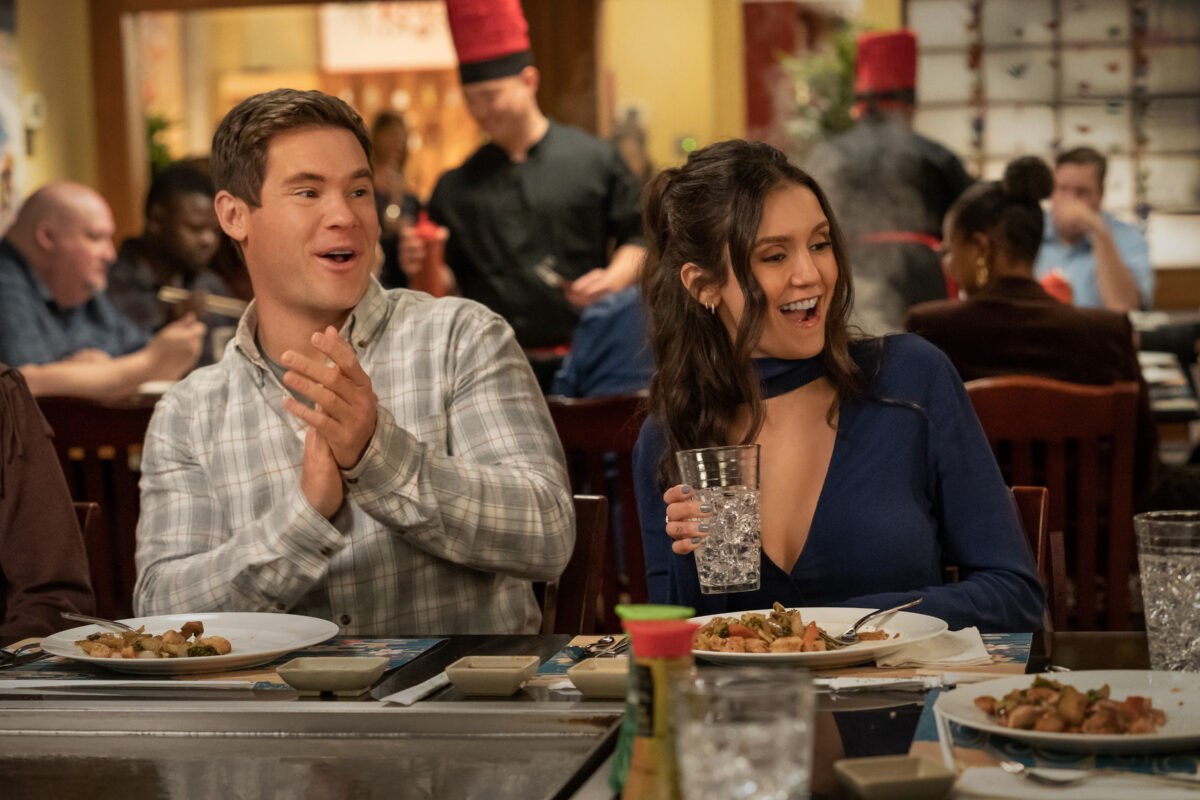Could you weave a creative story about the characters' background? Sure! Let's imagine that these two characters, Jessica and Alex, met during their university years. Jessica, the vibrant and ambitious psychology major, always had a knack for making people smile. Alex, the witty and charming business student, was drawn to her infectious energy. Fast forward a few years, they're now in the bustling heart of New York City. Jessica is a renowned therapist, known for her unconventional yet effective methods, and Alex owns a chain of successful artisanal coffee shops. Their dynamic friendship has always been marked by their mutual support and encouragement. Tonight, they're celebrating the second anniversary of Alex's entrepreneurial venture, which Jessica had a significant role in conceptualizing. Their laughter and joy are testaments to the deep bond they share, and the restaurant is alive with the energy of their shared history and accomplishments. Imagine a wild scenario where they are secret agents meeting for a covert mission. What would their conversation look like? Agent Jessica and Agent Alex, known in their circles as 'The Dynamic Duo', are undercover at a bustling restaurant, their unsuspecting faces lit with feigned cheer. Jessica, undercover in a stylish blue off-the-shoulder top, grips her glass of water with calculated casualness. Her eyes, however, are scanning the room. Alex, mid-clap, chuckles heartily, but his mind is focused on their covert mission. Their whispered conversation goes something like this:

Jessica: *smiling* 'Did you get the intel from the chef?' 
Alex: *clapping* 'Indeed, it’s under plate 4B. Our contact will retrieve it once we leave.'
Jessica: *laughing* 'Perfect. We need him to secure the perimeter by midnight. Any sign of our target?' 
Alex: *nodding slightly* 'He walked in five minutes ago, wearing a red tie. We leave in exactly three minutes. Stay on your guard.'
Their laughter masks the intensity of their real mission - to intercept a crucial microchip exchange happening within the next hour. As they prepare to leave, their jovial expressions are the perfect cover for the high-stakes operation unfolding around them.  Describe a realistic and casual interaction between them. In this casual setting at the bustling restaurant, Jessica and Alex are old friends catching up over a nice meal.

Jessica: *laughing* 'Remember that time in college when we tried to cook Thanksgiving dinner and almost set the kitchen on fire?' 
Alex: *clapping lightly* 'Oh man, how could I forget? I’ve never seen so much smoke in one place! I’m just glad we managed to salvage the pie, though.'
Jessica: 'Yeah, that pie was legendary. Who knew you could make pecan pie without pecans?' *laughs*
Alex: 'Desperate times called for desperate measures! So, tell me, how’s the new job treating you?' 
Jessica: 'It’s been great! Challenging but rewarding. I’ve got this amazing team I’m leading now…' 
Their conversation flows easily, punctuated by shared laughter and reminisces, reflecting the warmth and comfort of long-lasting friendship.  Describe another realistic but more serious scenario. In this scene, Alex and Jessica might be discussing a serious matter.

Alex: *clapping hands together thoughtfully* 'So, about that business proposal you mentioned last week. Did you manage to finalize the presentation?' 
Jessica: *nodding, holding her glass of water* 'Yes, I did. But honestly, I’m a bit nervous about pitching it. It’s a huge opportunity, and I don’t want to mess it up.'
Alex: 'Don’t worry, Jessica. You’ve got this. Just remember to highlight the key benefits and show them how your plan stands out from the competition. I believe in you.'
Jessica: 'Thanks, Alex. I really appreciate your support. It means a lot, especially coming from someone who’s built a successful business from the ground up.'
Their expressions are filled with determination and mutual respect, reflecting the gravity of their discussion about important career milestones and aspirations. 